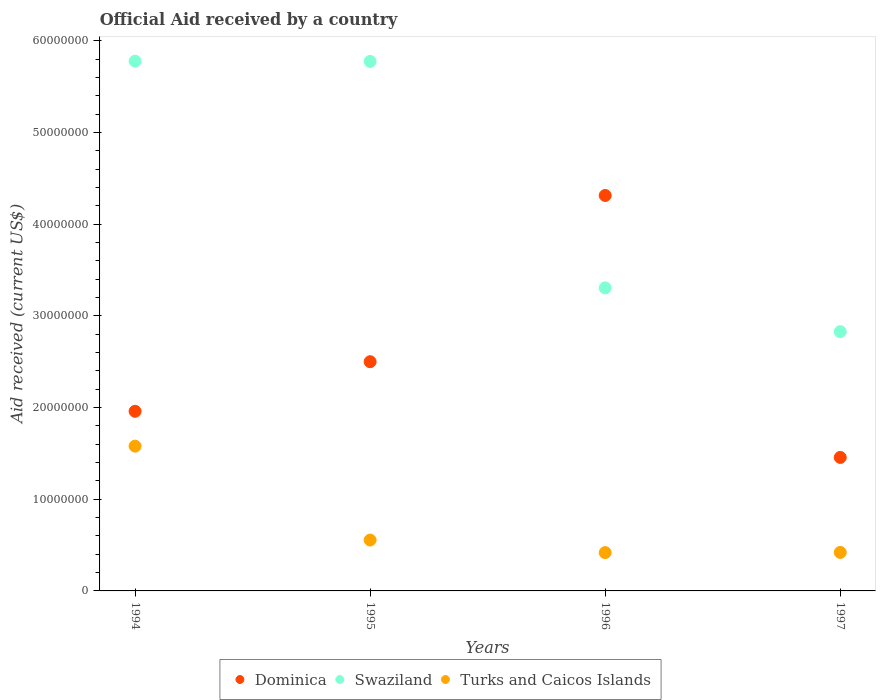How many different coloured dotlines are there?
Your response must be concise. 3. What is the net official aid received in Swaziland in 1996?
Your answer should be very brief. 3.30e+07. Across all years, what is the maximum net official aid received in Swaziland?
Provide a short and direct response. 5.78e+07. Across all years, what is the minimum net official aid received in Dominica?
Your answer should be compact. 1.46e+07. In which year was the net official aid received in Swaziland minimum?
Offer a very short reply. 1997. What is the total net official aid received in Turks and Caicos Islands in the graph?
Offer a terse response. 2.97e+07. What is the difference between the net official aid received in Dominica in 1994 and that in 1997?
Give a very brief answer. 5.03e+06. What is the difference between the net official aid received in Dominica in 1995 and the net official aid received in Swaziland in 1996?
Keep it short and to the point. -8.05e+06. What is the average net official aid received in Dominica per year?
Your answer should be very brief. 2.56e+07. In the year 1995, what is the difference between the net official aid received in Swaziland and net official aid received in Dominica?
Provide a succinct answer. 3.28e+07. In how many years, is the net official aid received in Swaziland greater than 6000000 US$?
Your response must be concise. 4. What is the ratio of the net official aid received in Turks and Caicos Islands in 1996 to that in 1997?
Give a very brief answer. 1. Is the difference between the net official aid received in Swaziland in 1994 and 1995 greater than the difference between the net official aid received in Dominica in 1994 and 1995?
Your answer should be compact. Yes. What is the difference between the highest and the second highest net official aid received in Turks and Caicos Islands?
Make the answer very short. 1.02e+07. What is the difference between the highest and the lowest net official aid received in Turks and Caicos Islands?
Your answer should be very brief. 1.16e+07. Does the net official aid received in Turks and Caicos Islands monotonically increase over the years?
Keep it short and to the point. No. How many years are there in the graph?
Your answer should be compact. 4. What is the difference between two consecutive major ticks on the Y-axis?
Make the answer very short. 1.00e+07. Are the values on the major ticks of Y-axis written in scientific E-notation?
Provide a succinct answer. No. Does the graph contain any zero values?
Offer a terse response. No. How many legend labels are there?
Offer a very short reply. 3. How are the legend labels stacked?
Offer a very short reply. Horizontal. What is the title of the graph?
Your answer should be very brief. Official Aid received by a country. What is the label or title of the X-axis?
Your response must be concise. Years. What is the label or title of the Y-axis?
Your answer should be compact. Aid received (current US$). What is the Aid received (current US$) in Dominica in 1994?
Give a very brief answer. 1.96e+07. What is the Aid received (current US$) of Swaziland in 1994?
Ensure brevity in your answer.  5.78e+07. What is the Aid received (current US$) in Turks and Caicos Islands in 1994?
Ensure brevity in your answer.  1.58e+07. What is the Aid received (current US$) of Dominica in 1995?
Offer a very short reply. 2.50e+07. What is the Aid received (current US$) of Swaziland in 1995?
Offer a terse response. 5.78e+07. What is the Aid received (current US$) in Turks and Caicos Islands in 1995?
Offer a very short reply. 5.55e+06. What is the Aid received (current US$) of Dominica in 1996?
Ensure brevity in your answer.  4.31e+07. What is the Aid received (current US$) in Swaziland in 1996?
Keep it short and to the point. 3.30e+07. What is the Aid received (current US$) in Turks and Caicos Islands in 1996?
Keep it short and to the point. 4.18e+06. What is the Aid received (current US$) of Dominica in 1997?
Keep it short and to the point. 1.46e+07. What is the Aid received (current US$) of Swaziland in 1997?
Provide a short and direct response. 2.83e+07. What is the Aid received (current US$) of Turks and Caicos Islands in 1997?
Your answer should be very brief. 4.20e+06. Across all years, what is the maximum Aid received (current US$) in Dominica?
Provide a succinct answer. 4.31e+07. Across all years, what is the maximum Aid received (current US$) of Swaziland?
Make the answer very short. 5.78e+07. Across all years, what is the maximum Aid received (current US$) of Turks and Caicos Islands?
Give a very brief answer. 1.58e+07. Across all years, what is the minimum Aid received (current US$) in Dominica?
Give a very brief answer. 1.46e+07. Across all years, what is the minimum Aid received (current US$) in Swaziland?
Your answer should be very brief. 2.83e+07. Across all years, what is the minimum Aid received (current US$) of Turks and Caicos Islands?
Offer a terse response. 4.18e+06. What is the total Aid received (current US$) in Dominica in the graph?
Keep it short and to the point. 1.02e+08. What is the total Aid received (current US$) of Swaziland in the graph?
Offer a very short reply. 1.77e+08. What is the total Aid received (current US$) of Turks and Caicos Islands in the graph?
Provide a short and direct response. 2.97e+07. What is the difference between the Aid received (current US$) of Dominica in 1994 and that in 1995?
Provide a succinct answer. -5.41e+06. What is the difference between the Aid received (current US$) in Turks and Caicos Islands in 1994 and that in 1995?
Keep it short and to the point. 1.02e+07. What is the difference between the Aid received (current US$) in Dominica in 1994 and that in 1996?
Keep it short and to the point. -2.35e+07. What is the difference between the Aid received (current US$) in Swaziland in 1994 and that in 1996?
Provide a short and direct response. 2.47e+07. What is the difference between the Aid received (current US$) in Turks and Caicos Islands in 1994 and that in 1996?
Your answer should be compact. 1.16e+07. What is the difference between the Aid received (current US$) of Dominica in 1994 and that in 1997?
Keep it short and to the point. 5.03e+06. What is the difference between the Aid received (current US$) in Swaziland in 1994 and that in 1997?
Your response must be concise. 2.95e+07. What is the difference between the Aid received (current US$) of Turks and Caicos Islands in 1994 and that in 1997?
Offer a very short reply. 1.16e+07. What is the difference between the Aid received (current US$) in Dominica in 1995 and that in 1996?
Keep it short and to the point. -1.81e+07. What is the difference between the Aid received (current US$) of Swaziland in 1995 and that in 1996?
Provide a succinct answer. 2.47e+07. What is the difference between the Aid received (current US$) in Turks and Caicos Islands in 1995 and that in 1996?
Your answer should be very brief. 1.37e+06. What is the difference between the Aid received (current US$) in Dominica in 1995 and that in 1997?
Provide a short and direct response. 1.04e+07. What is the difference between the Aid received (current US$) in Swaziland in 1995 and that in 1997?
Keep it short and to the point. 2.95e+07. What is the difference between the Aid received (current US$) in Turks and Caicos Islands in 1995 and that in 1997?
Your response must be concise. 1.35e+06. What is the difference between the Aid received (current US$) in Dominica in 1996 and that in 1997?
Offer a terse response. 2.86e+07. What is the difference between the Aid received (current US$) in Swaziland in 1996 and that in 1997?
Give a very brief answer. 4.77e+06. What is the difference between the Aid received (current US$) of Dominica in 1994 and the Aid received (current US$) of Swaziland in 1995?
Give a very brief answer. -3.82e+07. What is the difference between the Aid received (current US$) in Dominica in 1994 and the Aid received (current US$) in Turks and Caicos Islands in 1995?
Offer a terse response. 1.40e+07. What is the difference between the Aid received (current US$) of Swaziland in 1994 and the Aid received (current US$) of Turks and Caicos Islands in 1995?
Make the answer very short. 5.22e+07. What is the difference between the Aid received (current US$) in Dominica in 1994 and the Aid received (current US$) in Swaziland in 1996?
Offer a terse response. -1.35e+07. What is the difference between the Aid received (current US$) of Dominica in 1994 and the Aid received (current US$) of Turks and Caicos Islands in 1996?
Provide a succinct answer. 1.54e+07. What is the difference between the Aid received (current US$) of Swaziland in 1994 and the Aid received (current US$) of Turks and Caicos Islands in 1996?
Ensure brevity in your answer.  5.36e+07. What is the difference between the Aid received (current US$) in Dominica in 1994 and the Aid received (current US$) in Swaziland in 1997?
Give a very brief answer. -8.69e+06. What is the difference between the Aid received (current US$) in Dominica in 1994 and the Aid received (current US$) in Turks and Caicos Islands in 1997?
Provide a succinct answer. 1.54e+07. What is the difference between the Aid received (current US$) in Swaziland in 1994 and the Aid received (current US$) in Turks and Caicos Islands in 1997?
Your response must be concise. 5.36e+07. What is the difference between the Aid received (current US$) in Dominica in 1995 and the Aid received (current US$) in Swaziland in 1996?
Keep it short and to the point. -8.05e+06. What is the difference between the Aid received (current US$) in Dominica in 1995 and the Aid received (current US$) in Turks and Caicos Islands in 1996?
Your answer should be compact. 2.08e+07. What is the difference between the Aid received (current US$) in Swaziland in 1995 and the Aid received (current US$) in Turks and Caicos Islands in 1996?
Make the answer very short. 5.36e+07. What is the difference between the Aid received (current US$) in Dominica in 1995 and the Aid received (current US$) in Swaziland in 1997?
Your answer should be very brief. -3.28e+06. What is the difference between the Aid received (current US$) of Dominica in 1995 and the Aid received (current US$) of Turks and Caicos Islands in 1997?
Provide a succinct answer. 2.08e+07. What is the difference between the Aid received (current US$) of Swaziland in 1995 and the Aid received (current US$) of Turks and Caicos Islands in 1997?
Your response must be concise. 5.36e+07. What is the difference between the Aid received (current US$) of Dominica in 1996 and the Aid received (current US$) of Swaziland in 1997?
Provide a short and direct response. 1.48e+07. What is the difference between the Aid received (current US$) in Dominica in 1996 and the Aid received (current US$) in Turks and Caicos Islands in 1997?
Provide a short and direct response. 3.89e+07. What is the difference between the Aid received (current US$) of Swaziland in 1996 and the Aid received (current US$) of Turks and Caicos Islands in 1997?
Your answer should be compact. 2.88e+07. What is the average Aid received (current US$) of Dominica per year?
Ensure brevity in your answer.  2.56e+07. What is the average Aid received (current US$) of Swaziland per year?
Your answer should be compact. 4.42e+07. What is the average Aid received (current US$) in Turks and Caicos Islands per year?
Keep it short and to the point. 7.43e+06. In the year 1994, what is the difference between the Aid received (current US$) of Dominica and Aid received (current US$) of Swaziland?
Ensure brevity in your answer.  -3.82e+07. In the year 1994, what is the difference between the Aid received (current US$) of Dominica and Aid received (current US$) of Turks and Caicos Islands?
Your response must be concise. 3.80e+06. In the year 1994, what is the difference between the Aid received (current US$) of Swaziland and Aid received (current US$) of Turks and Caicos Islands?
Make the answer very short. 4.20e+07. In the year 1995, what is the difference between the Aid received (current US$) in Dominica and Aid received (current US$) in Swaziland?
Ensure brevity in your answer.  -3.28e+07. In the year 1995, what is the difference between the Aid received (current US$) of Dominica and Aid received (current US$) of Turks and Caicos Islands?
Your answer should be very brief. 1.94e+07. In the year 1995, what is the difference between the Aid received (current US$) of Swaziland and Aid received (current US$) of Turks and Caicos Islands?
Make the answer very short. 5.22e+07. In the year 1996, what is the difference between the Aid received (current US$) of Dominica and Aid received (current US$) of Swaziland?
Keep it short and to the point. 1.01e+07. In the year 1996, what is the difference between the Aid received (current US$) of Dominica and Aid received (current US$) of Turks and Caicos Islands?
Make the answer very short. 3.90e+07. In the year 1996, what is the difference between the Aid received (current US$) of Swaziland and Aid received (current US$) of Turks and Caicos Islands?
Your answer should be very brief. 2.89e+07. In the year 1997, what is the difference between the Aid received (current US$) of Dominica and Aid received (current US$) of Swaziland?
Offer a very short reply. -1.37e+07. In the year 1997, what is the difference between the Aid received (current US$) in Dominica and Aid received (current US$) in Turks and Caicos Islands?
Your response must be concise. 1.04e+07. In the year 1997, what is the difference between the Aid received (current US$) of Swaziland and Aid received (current US$) of Turks and Caicos Islands?
Offer a very short reply. 2.41e+07. What is the ratio of the Aid received (current US$) in Dominica in 1994 to that in 1995?
Keep it short and to the point. 0.78. What is the ratio of the Aid received (current US$) in Swaziland in 1994 to that in 1995?
Your response must be concise. 1. What is the ratio of the Aid received (current US$) in Turks and Caicos Islands in 1994 to that in 1995?
Offer a very short reply. 2.85. What is the ratio of the Aid received (current US$) of Dominica in 1994 to that in 1996?
Provide a short and direct response. 0.45. What is the ratio of the Aid received (current US$) of Swaziland in 1994 to that in 1996?
Offer a very short reply. 1.75. What is the ratio of the Aid received (current US$) of Turks and Caicos Islands in 1994 to that in 1996?
Provide a short and direct response. 3.78. What is the ratio of the Aid received (current US$) in Dominica in 1994 to that in 1997?
Provide a short and direct response. 1.35. What is the ratio of the Aid received (current US$) in Swaziland in 1994 to that in 1997?
Give a very brief answer. 2.04. What is the ratio of the Aid received (current US$) in Turks and Caicos Islands in 1994 to that in 1997?
Your answer should be very brief. 3.76. What is the ratio of the Aid received (current US$) of Dominica in 1995 to that in 1996?
Give a very brief answer. 0.58. What is the ratio of the Aid received (current US$) of Swaziland in 1995 to that in 1996?
Offer a terse response. 1.75. What is the ratio of the Aid received (current US$) in Turks and Caicos Islands in 1995 to that in 1996?
Your answer should be compact. 1.33. What is the ratio of the Aid received (current US$) in Dominica in 1995 to that in 1997?
Your answer should be compact. 1.72. What is the ratio of the Aid received (current US$) in Swaziland in 1995 to that in 1997?
Your response must be concise. 2.04. What is the ratio of the Aid received (current US$) of Turks and Caicos Islands in 1995 to that in 1997?
Provide a short and direct response. 1.32. What is the ratio of the Aid received (current US$) in Dominica in 1996 to that in 1997?
Offer a terse response. 2.96. What is the ratio of the Aid received (current US$) of Swaziland in 1996 to that in 1997?
Your response must be concise. 1.17. What is the difference between the highest and the second highest Aid received (current US$) in Dominica?
Give a very brief answer. 1.81e+07. What is the difference between the highest and the second highest Aid received (current US$) in Turks and Caicos Islands?
Give a very brief answer. 1.02e+07. What is the difference between the highest and the lowest Aid received (current US$) in Dominica?
Offer a terse response. 2.86e+07. What is the difference between the highest and the lowest Aid received (current US$) of Swaziland?
Provide a short and direct response. 2.95e+07. What is the difference between the highest and the lowest Aid received (current US$) in Turks and Caicos Islands?
Provide a short and direct response. 1.16e+07. 